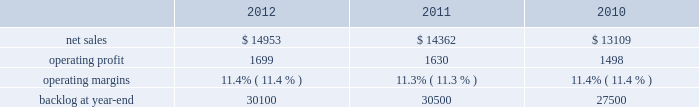Aeronautics business segment 2019s results of operations discussion .
The increase in our consolidated net adjustments for 2011 as compared to 2010 primarily was due to an increase in profit booking rate adjustments at our is&gs and aeronautics business segments .
Aeronautics our aeronautics business segment is engaged in the research , design , development , manufacture , integration , sustainment , support , and upgrade of advanced military aircraft , including combat and air mobility aircraft , unmanned air vehicles , and related technologies .
Aeronautics 2019 major programs include the f-35 lightning ii joint strike fighter , f-22 raptor , f-16 fighting falcon , c-130 hercules , and the c-5m super galaxy .
Aeronautics 2019 operating results included the following ( in millions ) : .
2012 compared to 2011 aeronautics 2019 net sales for 2012 increased $ 591 million , or 4% ( 4 % ) , compared to 2011 .
The increase was attributable to higher net sales of approximately $ 745 million from f-35 lrip contracts principally due to increased production volume ; about $ 285 million from f-16 programs primarily due to higher aircraft deliveries ( 37 f-16 aircraft delivered in 2012 compared to 22 in 2011 ) partially offset by lower volume on sustainment activities due to the completion of modification programs for certain international customers ; and approximately $ 140 million from c-5 programs due to higher aircraft deliveries ( four c-5m aircraft delivered in 2012 compared to two in 2011 ) .
Partially offsetting the increases were lower net sales of approximately $ 365 million from decreased production volume and lower risk retirements on the f-22 program as final aircraft deliveries were completed in the second quarter of 2012 ; approximately $ 110 million from the f-35 development contract primarily due to the inception-to-date effect of reducing the profit booking rate in the second quarter of 2012 and to a lesser extent lower volume ; and about $ 95 million from a decrease in volume on other sustainment activities partially offset by various other aeronautics programs due to higher volume .
Net sales for c-130 programs were comparable to 2011 as a decline in sustainment activities largely was offset by increased aircraft deliveries .
Aeronautics 2019 operating profit for 2012 increased $ 69 million , or 4% ( 4 % ) , compared to 2011 .
The increase was attributable to higher operating profit of approximately $ 105 million from c-130 programs due to an increase in risk retirements ; about $ 50 million from f-16 programs due to higher aircraft deliveries partially offset by a decline in risk retirements ; approximately $ 50 million from f-35 lrip contracts due to increased production volume and risk retirements ; and about $ 50 million from the completion of purchased intangible asset amortization on certain f-16 contracts .
Partially offsetting the increases was lower operating profit of about $ 90 million from the f-35 development contract primarily due to the inception- to-date effect of reducing the profit booking rate in the second quarter of 2012 ; approximately $ 50 million from decreased production volume and risk retirements on the f-22 program partially offset by a resolution of a contractual matter in the second quarter of 2012 ; and approximately $ 45 million primarily due to a decrease in risk retirements on other sustainment activities partially offset by various other aeronautics programs due to increased risk retirements and volume .
Operating profit for c-5 programs was comparable to 2011 .
Adjustments not related to volume , including net profit booking rate adjustments and other matters described above , were approximately $ 30 million lower for 2012 compared to 2011 .
2011 compared to 2010 aeronautics 2019 net sales for 2011 increased $ 1.3 billion , or 10% ( 10 % ) , compared to 2010 .
The growth in net sales primarily was due to higher volume of about $ 850 million for work performed on the f-35 lrip contracts as production increased ; higher volume of about $ 745 million for c-130 programs due to an increase in deliveries ( 33 c-130j aircraft delivered in 2011 compared to 25 during 2010 ) and support activities ; about $ 425 million for f-16 support activities and an increase in aircraft deliveries ( 22 f-16 aircraft delivered in 2011 compared to 20 during 2010 ) ; and approximately $ 90 million for higher volume on c-5 programs ( two c-5m aircraft delivered in 2011 compared to one during 2010 ) .
These increases partially were offset by a decline in net sales of approximately $ 675 million due to lower volume on the f-22 program and lower net sales of about $ 155 million for the f-35 development contract as development work decreased. .
What was the percent of the growth in the sales from 2011 to 2012? 
Computations: ((14953 - 14362) / 14362)
Answer: 0.04115. Aeronautics business segment 2019s results of operations discussion .
The increase in our consolidated net adjustments for 2011 as compared to 2010 primarily was due to an increase in profit booking rate adjustments at our is&gs and aeronautics business segments .
Aeronautics our aeronautics business segment is engaged in the research , design , development , manufacture , integration , sustainment , support , and upgrade of advanced military aircraft , including combat and air mobility aircraft , unmanned air vehicles , and related technologies .
Aeronautics 2019 major programs include the f-35 lightning ii joint strike fighter , f-22 raptor , f-16 fighting falcon , c-130 hercules , and the c-5m super galaxy .
Aeronautics 2019 operating results included the following ( in millions ) : .
2012 compared to 2011 aeronautics 2019 net sales for 2012 increased $ 591 million , or 4% ( 4 % ) , compared to 2011 .
The increase was attributable to higher net sales of approximately $ 745 million from f-35 lrip contracts principally due to increased production volume ; about $ 285 million from f-16 programs primarily due to higher aircraft deliveries ( 37 f-16 aircraft delivered in 2012 compared to 22 in 2011 ) partially offset by lower volume on sustainment activities due to the completion of modification programs for certain international customers ; and approximately $ 140 million from c-5 programs due to higher aircraft deliveries ( four c-5m aircraft delivered in 2012 compared to two in 2011 ) .
Partially offsetting the increases were lower net sales of approximately $ 365 million from decreased production volume and lower risk retirements on the f-22 program as final aircraft deliveries were completed in the second quarter of 2012 ; approximately $ 110 million from the f-35 development contract primarily due to the inception-to-date effect of reducing the profit booking rate in the second quarter of 2012 and to a lesser extent lower volume ; and about $ 95 million from a decrease in volume on other sustainment activities partially offset by various other aeronautics programs due to higher volume .
Net sales for c-130 programs were comparable to 2011 as a decline in sustainment activities largely was offset by increased aircraft deliveries .
Aeronautics 2019 operating profit for 2012 increased $ 69 million , or 4% ( 4 % ) , compared to 2011 .
The increase was attributable to higher operating profit of approximately $ 105 million from c-130 programs due to an increase in risk retirements ; about $ 50 million from f-16 programs due to higher aircraft deliveries partially offset by a decline in risk retirements ; approximately $ 50 million from f-35 lrip contracts due to increased production volume and risk retirements ; and about $ 50 million from the completion of purchased intangible asset amortization on certain f-16 contracts .
Partially offsetting the increases was lower operating profit of about $ 90 million from the f-35 development contract primarily due to the inception- to-date effect of reducing the profit booking rate in the second quarter of 2012 ; approximately $ 50 million from decreased production volume and risk retirements on the f-22 program partially offset by a resolution of a contractual matter in the second quarter of 2012 ; and approximately $ 45 million primarily due to a decrease in risk retirements on other sustainment activities partially offset by various other aeronautics programs due to increased risk retirements and volume .
Operating profit for c-5 programs was comparable to 2011 .
Adjustments not related to volume , including net profit booking rate adjustments and other matters described above , were approximately $ 30 million lower for 2012 compared to 2011 .
2011 compared to 2010 aeronautics 2019 net sales for 2011 increased $ 1.3 billion , or 10% ( 10 % ) , compared to 2010 .
The growth in net sales primarily was due to higher volume of about $ 850 million for work performed on the f-35 lrip contracts as production increased ; higher volume of about $ 745 million for c-130 programs due to an increase in deliveries ( 33 c-130j aircraft delivered in 2011 compared to 25 during 2010 ) and support activities ; about $ 425 million for f-16 support activities and an increase in aircraft deliveries ( 22 f-16 aircraft delivered in 2011 compared to 20 during 2010 ) ; and approximately $ 90 million for higher volume on c-5 programs ( two c-5m aircraft delivered in 2011 compared to one during 2010 ) .
These increases partially were offset by a decline in net sales of approximately $ 675 million due to lower volume on the f-22 program and lower net sales of about $ 155 million for the f-35 development contract as development work decreased. .
What is the growth rate in operating profit for aeronautics in 2012? 
Computations: ((1699 - 1630) / 1630)
Answer: 0.04233. 